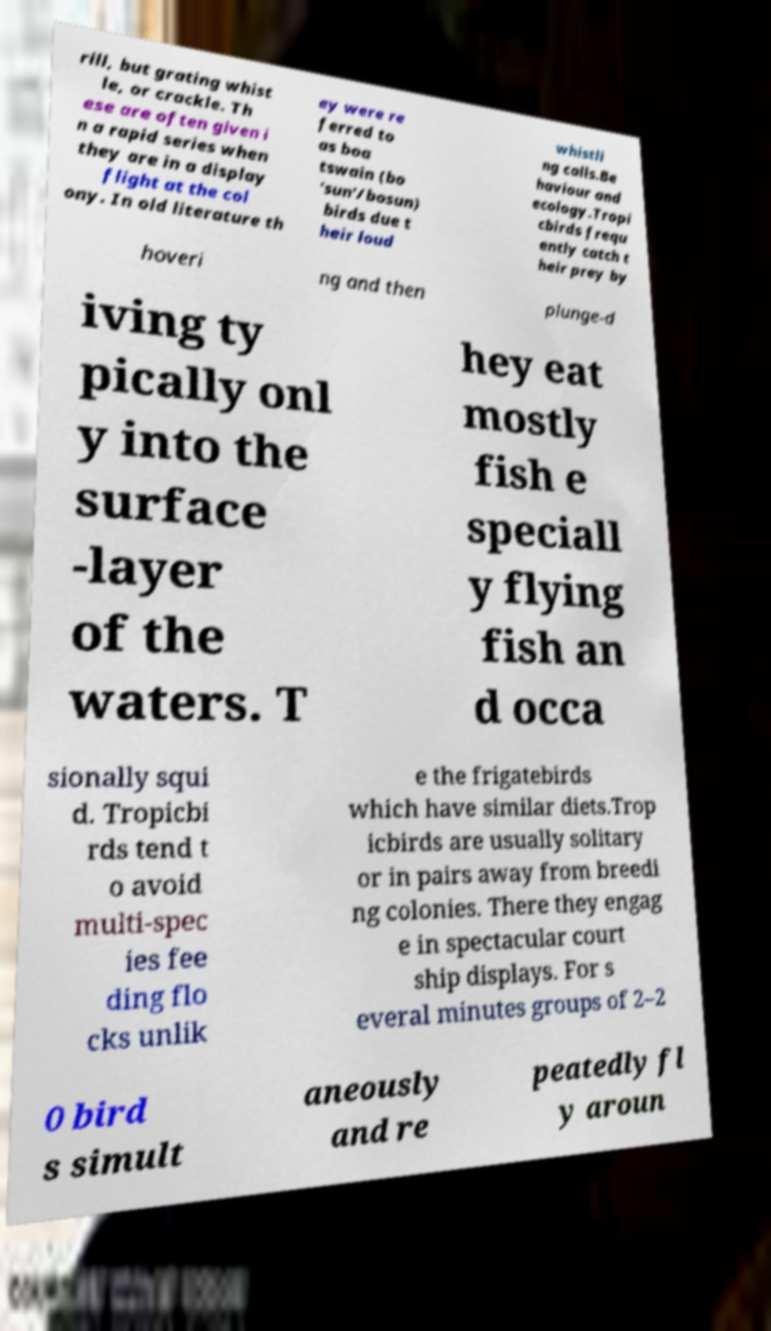Please read and relay the text visible in this image. What does it say? rill, but grating whist le, or crackle. Th ese are often given i n a rapid series when they are in a display flight at the col ony. In old literature th ey were re ferred to as boa tswain (bo 'sun'/bosun) birds due t heir loud whistli ng calls.Be haviour and ecology.Tropi cbirds frequ ently catch t heir prey by hoveri ng and then plunge-d iving ty pically onl y into the surface -layer of the waters. T hey eat mostly fish e speciall y flying fish an d occa sionally squi d. Tropicbi rds tend t o avoid multi-spec ies fee ding flo cks unlik e the frigatebirds which have similar diets.Trop icbirds are usually solitary or in pairs away from breedi ng colonies. There they engag e in spectacular court ship displays. For s everal minutes groups of 2–2 0 bird s simult aneously and re peatedly fl y aroun 